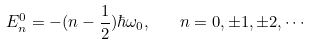<formula> <loc_0><loc_0><loc_500><loc_500>E _ { n } ^ { 0 } = - ( n - \frac { 1 } { 2 } ) \hbar { \omega } _ { 0 } , \quad n = 0 , \pm 1 , \pm 2 , \cdots</formula> 